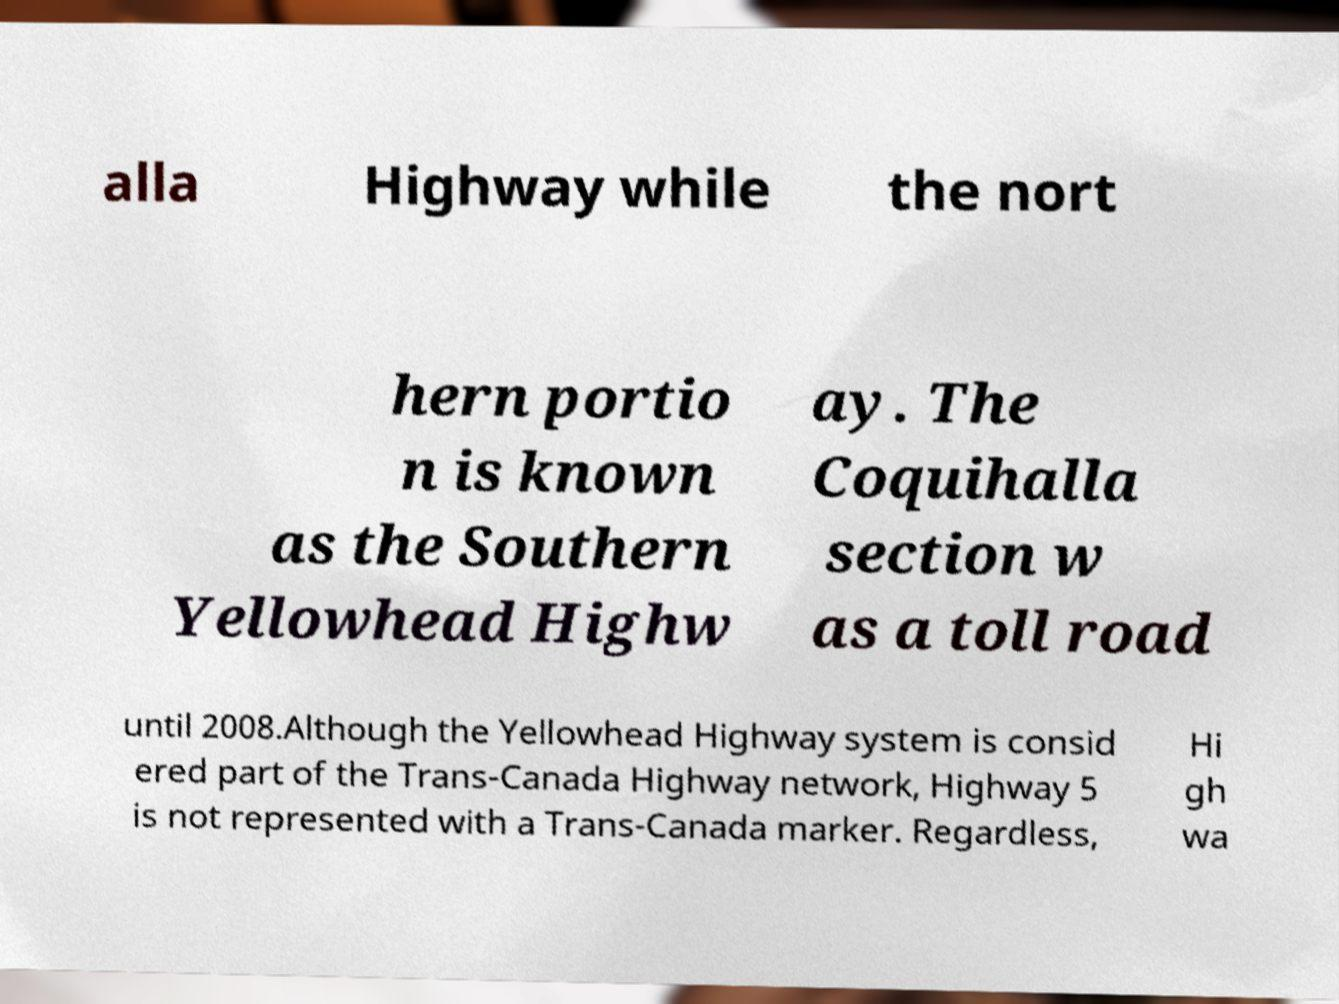There's text embedded in this image that I need extracted. Can you transcribe it verbatim? alla Highway while the nort hern portio n is known as the Southern Yellowhead Highw ay. The Coquihalla section w as a toll road until 2008.Although the Yellowhead Highway system is consid ered part of the Trans-Canada Highway network, Highway 5 is not represented with a Trans-Canada marker. Regardless, Hi gh wa 